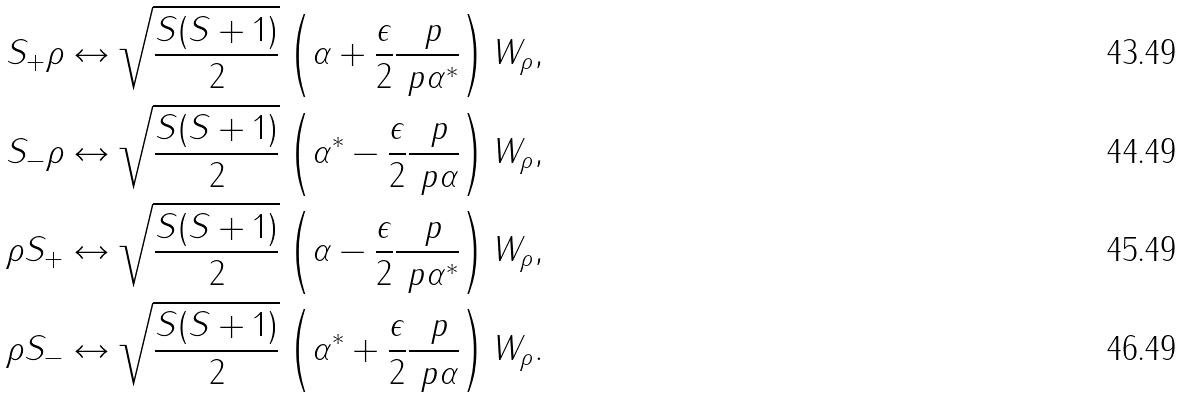Convert formula to latex. <formula><loc_0><loc_0><loc_500><loc_500>S _ { + } \rho & \leftrightarrow \sqrt { \frac { S ( S + 1 ) } { 2 } } \left ( \alpha + \frac { \epsilon } { 2 } \frac { \ p } { \ p \alpha ^ { * } } \right ) W _ { \rho } , \\ S _ { - } \rho & \leftrightarrow \sqrt { \frac { S ( S + 1 ) } { 2 } } \left ( \alpha ^ { * } - \frac { \epsilon } { 2 } \frac { \ p } { \ p \alpha } \right ) W _ { \rho } , \\ \rho S _ { + } & \leftrightarrow \sqrt { \frac { S ( S + 1 ) } { 2 } } \left ( \alpha - \frac { \epsilon } { 2 } \frac { \ p } { \ p \alpha ^ { * } } \right ) W _ { \rho } , \\ \rho S _ { - } & \leftrightarrow \sqrt { \frac { S ( S + 1 ) } { 2 } } \left ( \alpha ^ { * } + \frac { \epsilon } { 2 } \frac { \ p } { \ p \alpha } \right ) W _ { \rho } .</formula> 